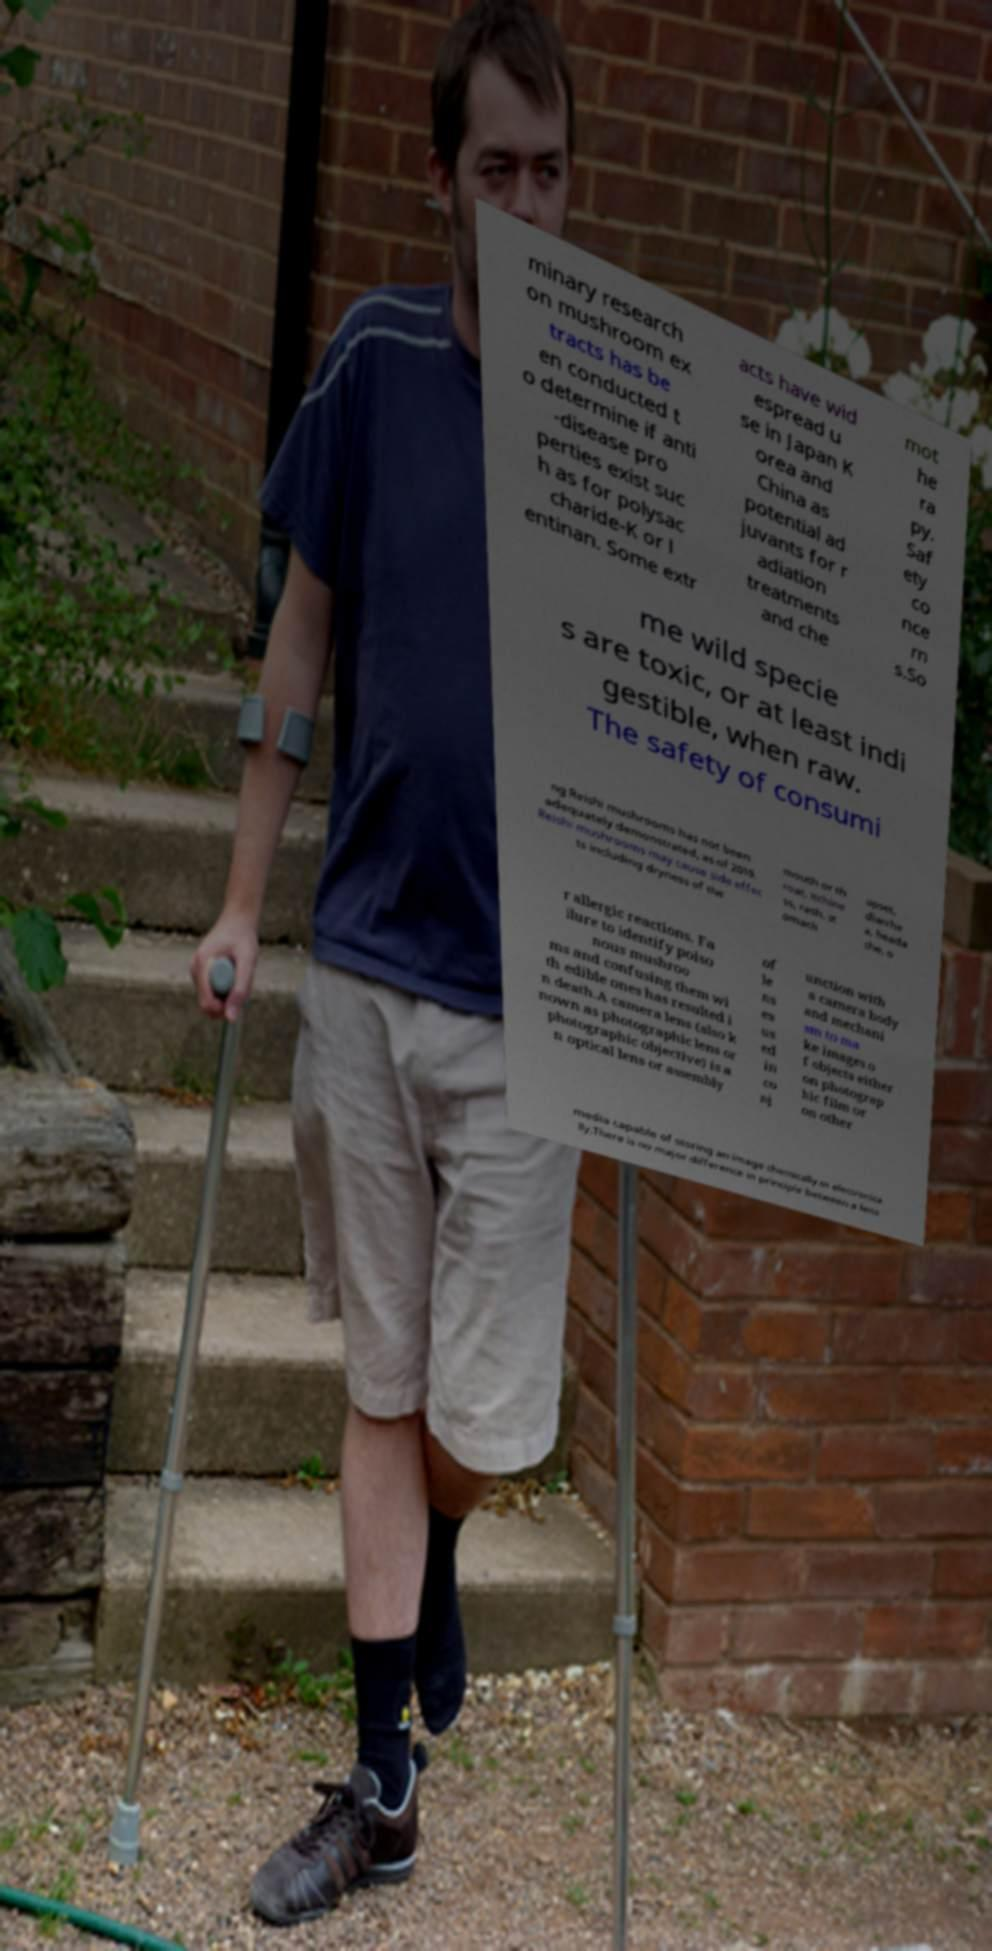Please read and relay the text visible in this image. What does it say? minary research on mushroom ex tracts has be en conducted t o determine if anti -disease pro perties exist suc h as for polysac charide-K or l entinan. Some extr acts have wid espread u se in Japan K orea and China as potential ad juvants for r adiation treatments and che mot he ra py. Saf ety co nce rn s.So me wild specie s are toxic, or at least indi gestible, when raw. The safety of consumi ng Reishi mushrooms has not been adequately demonstrated, as of 2019. Reishi mushrooms may cause side effec ts including dryness of the mouth or th roat, itchine ss, rash, st omach upset, diarrhe a, heada che, o r allergic reactions. Fa ilure to identify poiso nous mushroo ms and confusing them wi th edible ones has resulted i n death.A camera lens (also k nown as photographic lens or photographic objective) is a n optical lens or assembly of le ns es us ed in co nj unction with a camera body and mechani sm to ma ke images o f objects either on photograp hic film or on other media capable of storing an image chemically or electronica lly.There is no major difference in principle between a lens 